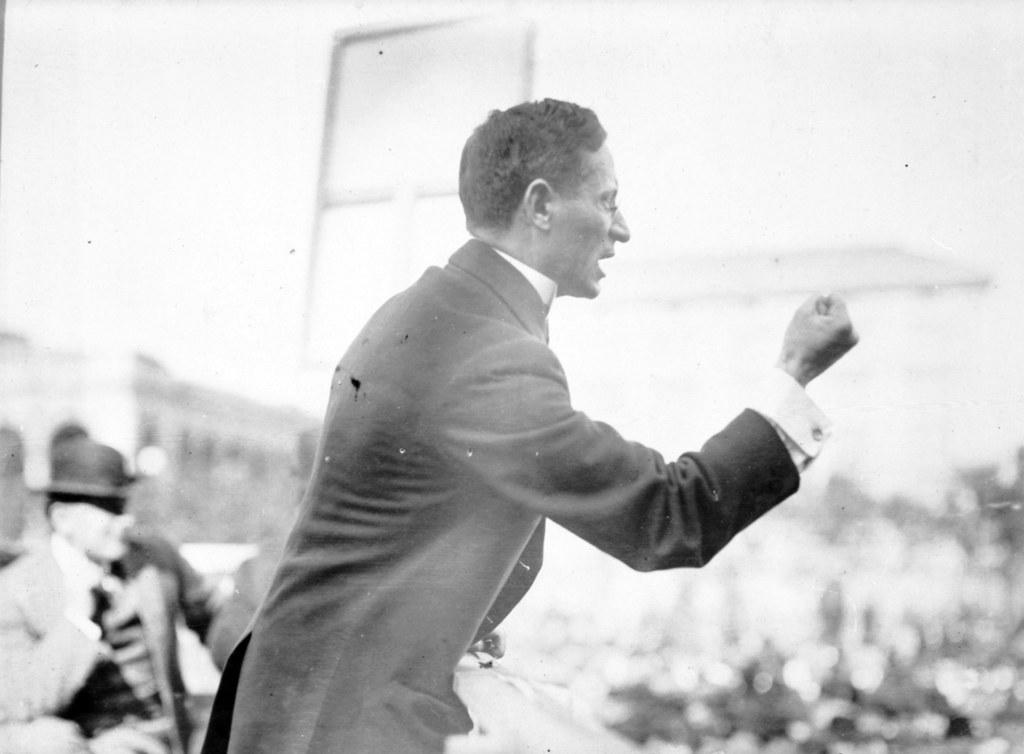What is the primary action of the person in the image? There is a person standing in the image. What type of clothing is the standing person wearing? The standing person is wearing a blazer. What is the position of the second person in the image? There is a person sitting in the image. What color scheme is used in the image? The image is in black and white. What type of system is being used by the company in the image? There is no mention of a system or company in the image; it only features two people, one standing and one sitting. 